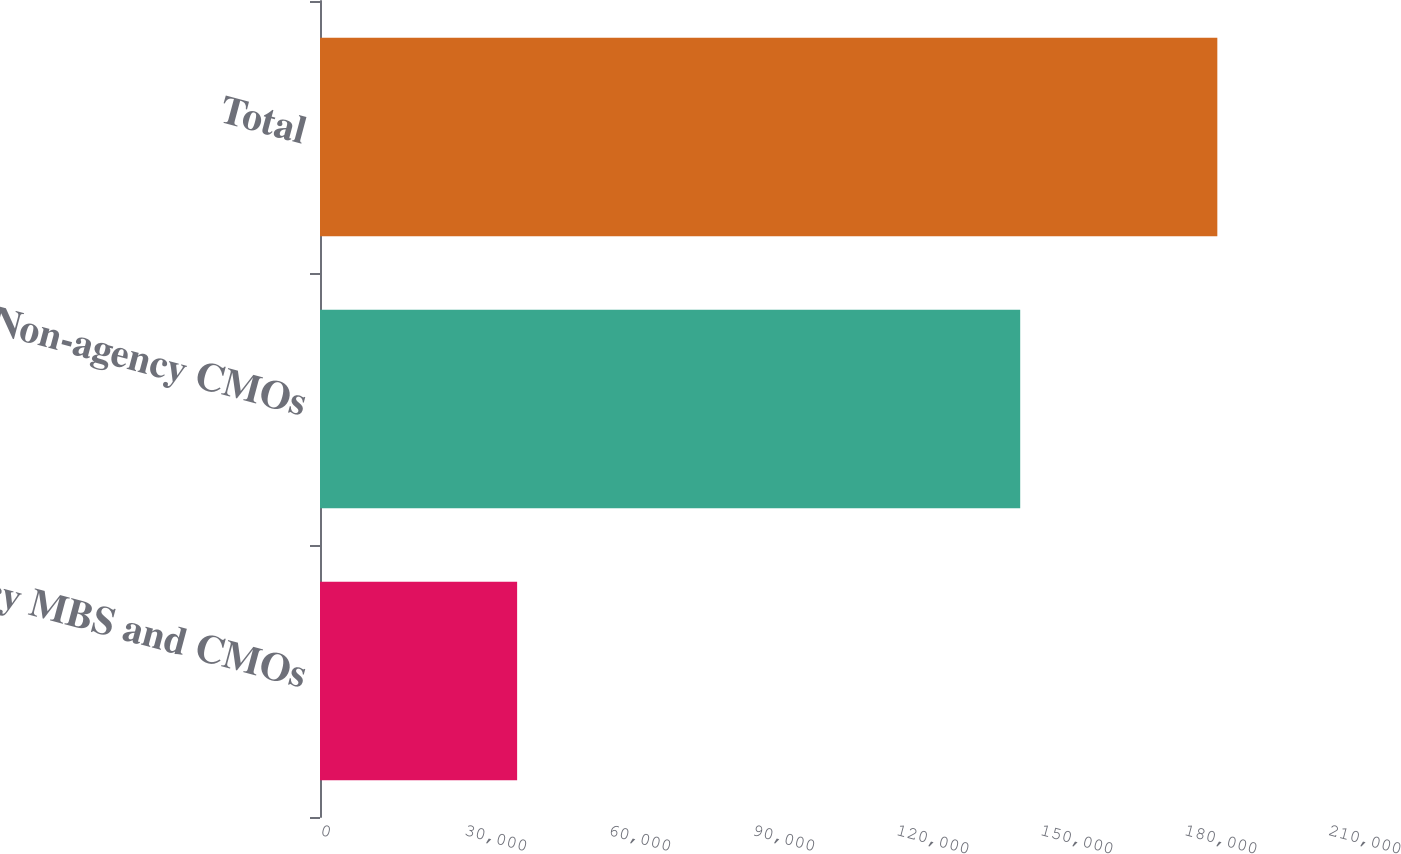Convert chart. <chart><loc_0><loc_0><loc_500><loc_500><bar_chart><fcel>Agency MBS and CMOs<fcel>Non-agency CMOs<fcel>Total<nl><fcel>41068<fcel>145875<fcel>186943<nl></chart> 